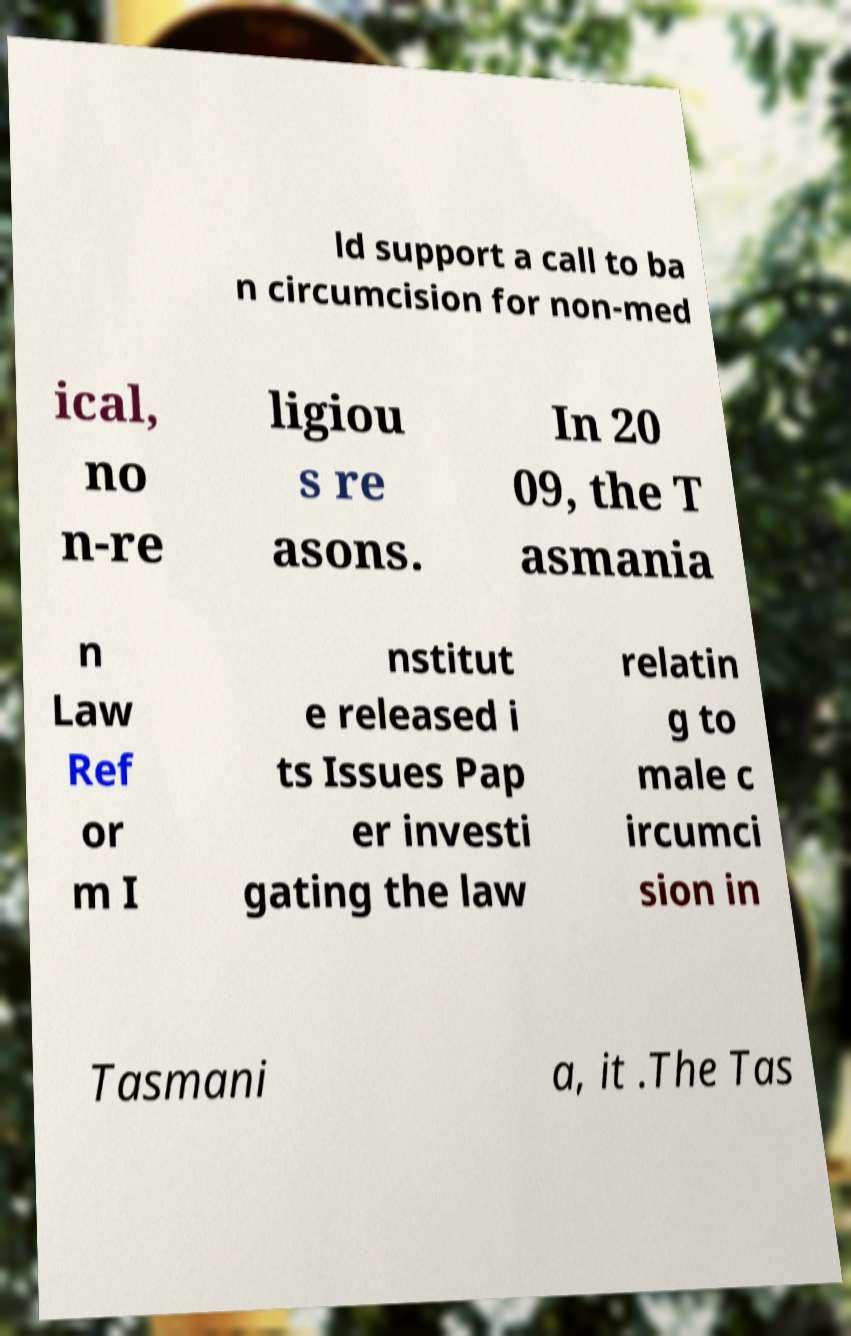I need the written content from this picture converted into text. Can you do that? ld support a call to ba n circumcision for non-med ical, no n-re ligiou s re asons. In 20 09, the T asmania n Law Ref or m I nstitut e released i ts Issues Pap er investi gating the law relatin g to male c ircumci sion in Tasmani a, it .The Tas 